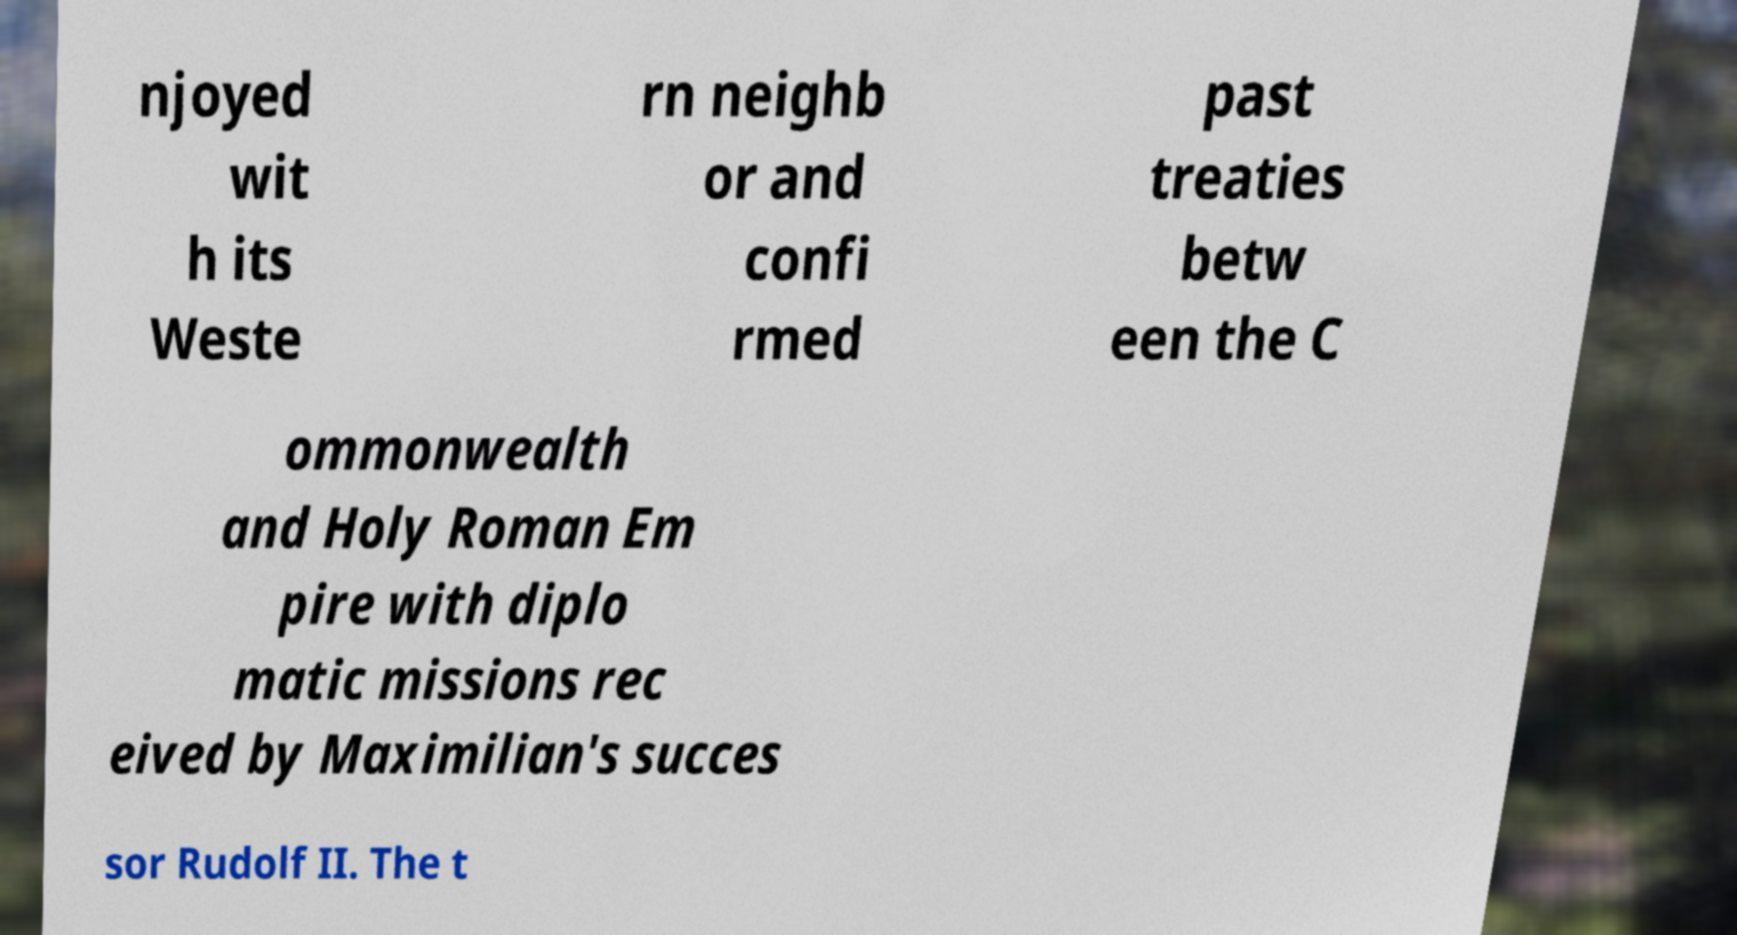What messages or text are displayed in this image? I need them in a readable, typed format. njoyed wit h its Weste rn neighb or and confi rmed past treaties betw een the C ommonwealth and Holy Roman Em pire with diplo matic missions rec eived by Maximilian's succes sor Rudolf II. The t 